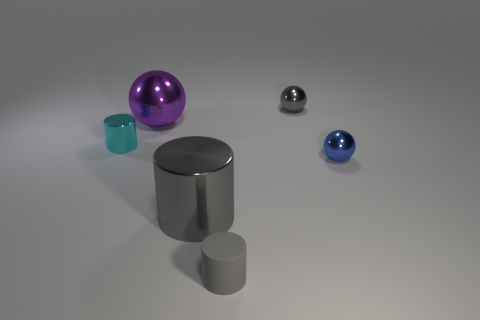Can you describe the lighting setup that might have been used to achieve the shadows in this image? The lighting in this image seems to be coming from a source above and to the right of the objects, likely a single bright light, due to the sharpness and direction of the shadows cast by each object. 